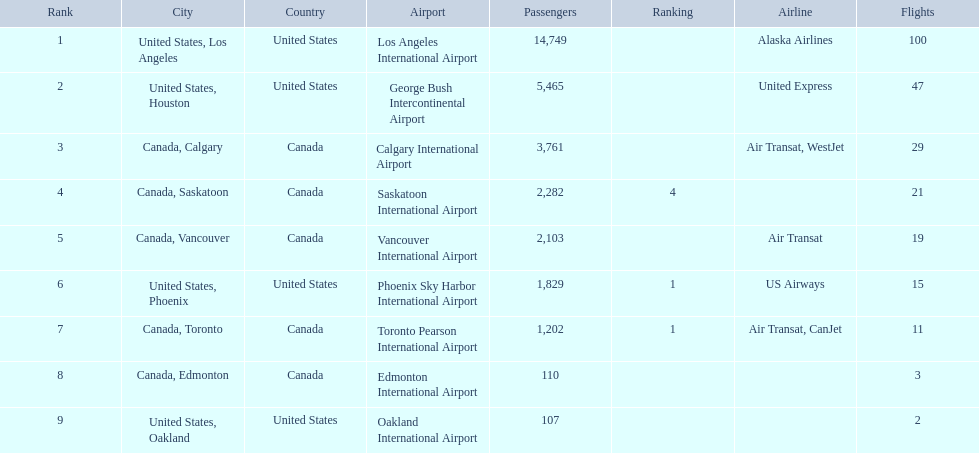What cities do the planes fly to? United States, Los Angeles, United States, Houston, Canada, Calgary, Canada, Saskatoon, Canada, Vancouver, United States, Phoenix, Canada, Toronto, Canada, Edmonton, United States, Oakland. How many people are flying to phoenix, arizona? 1,829. 